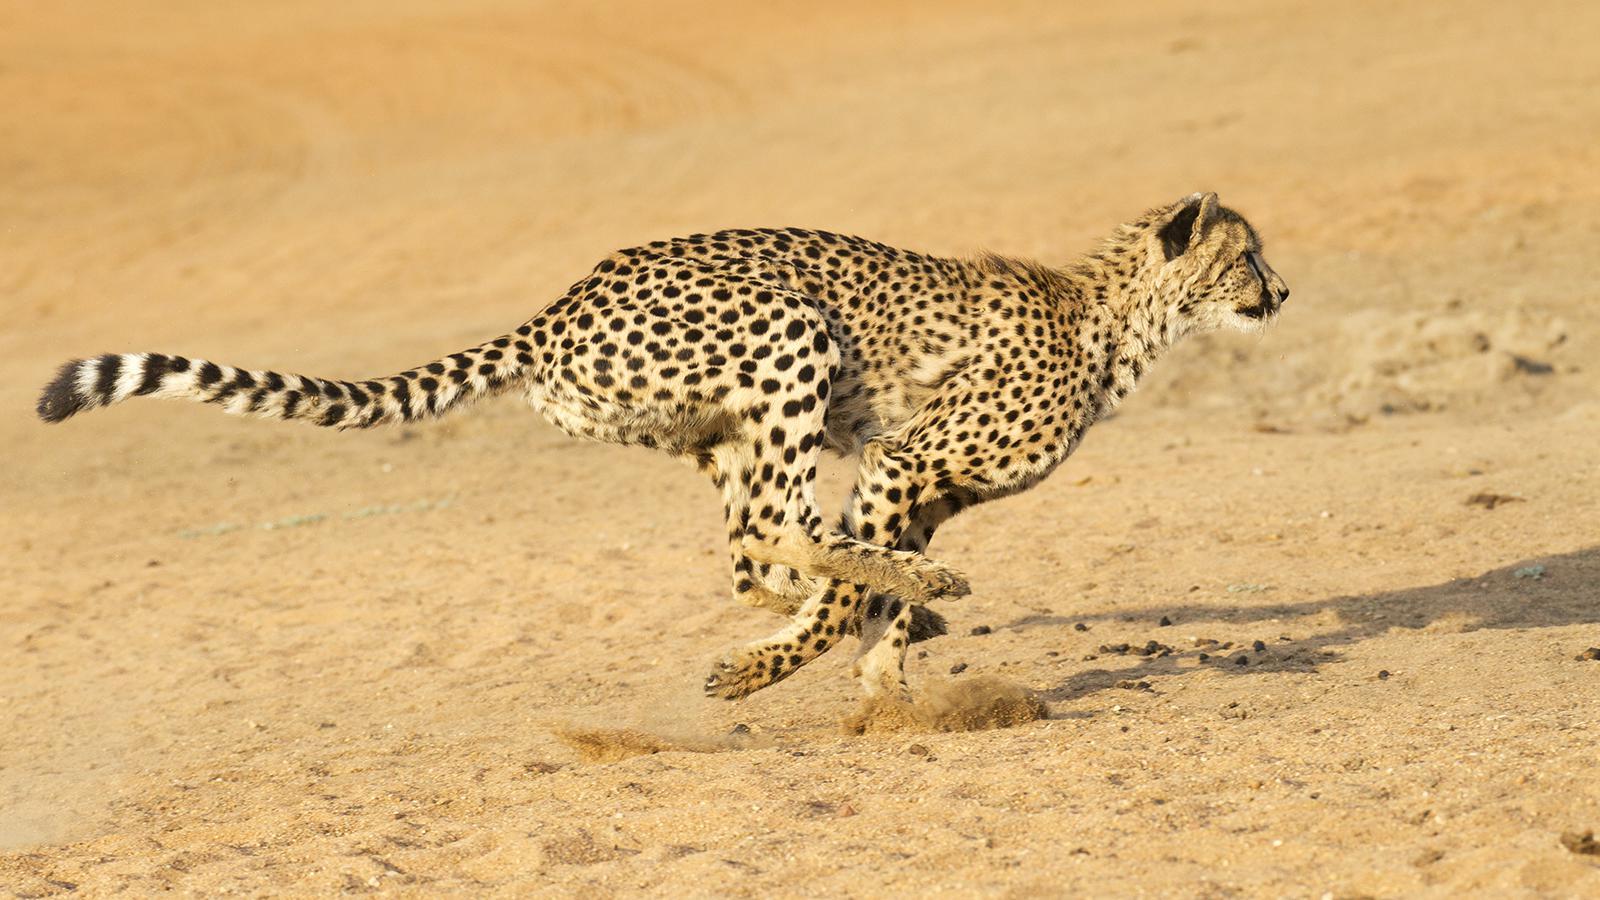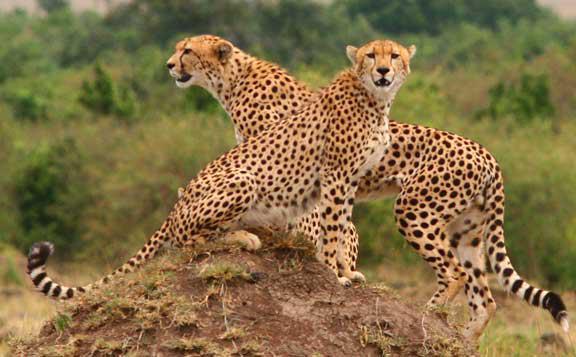The first image is the image on the left, the second image is the image on the right. Examine the images to the left and right. Is the description "You'll notice a handful of cheetah cubs in one of the images." accurate? Answer yes or no. No. 